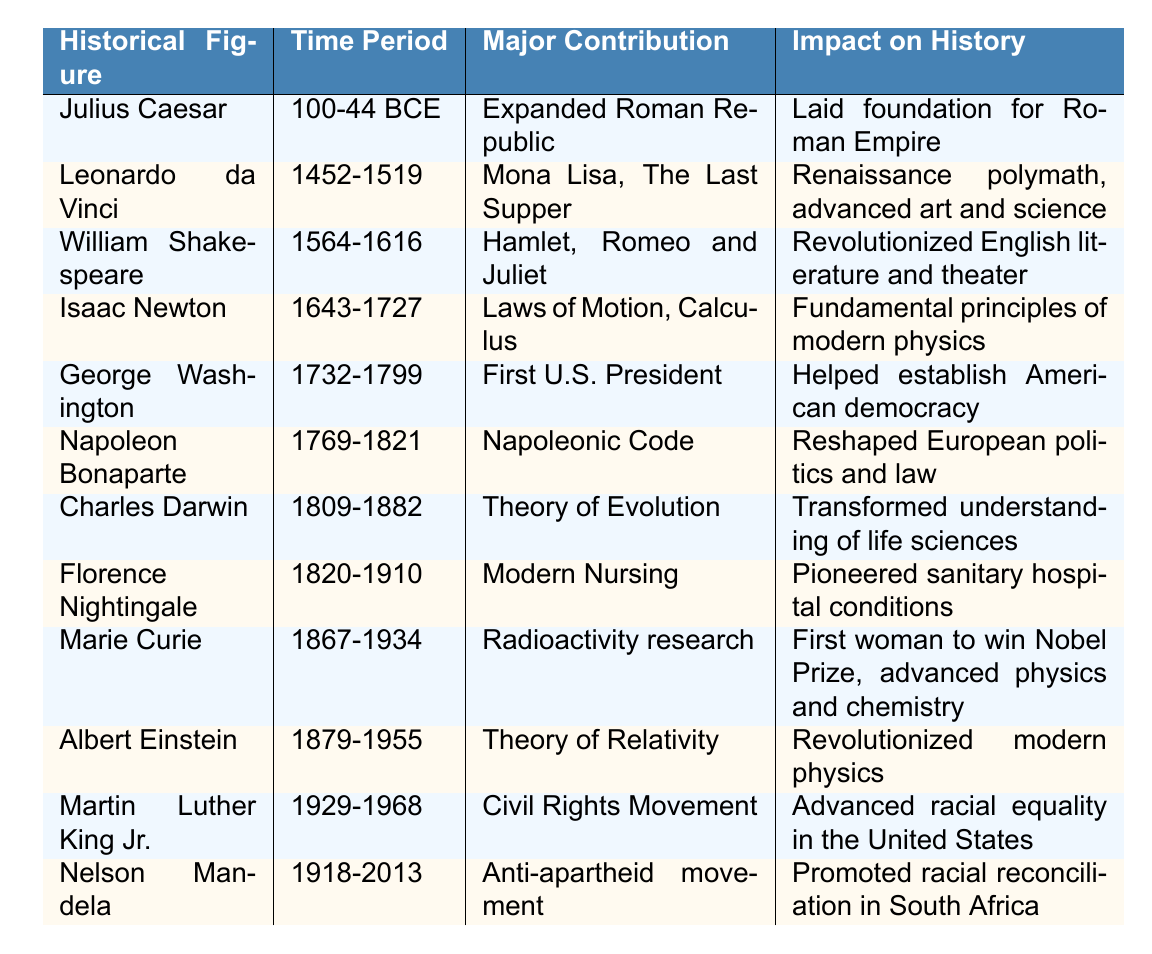What is the major contribution of Isaac Newton? The table displays that Isaac Newton's major contribution is the "Laws of Motion, Calculus." This information is directly found in the row corresponding to Isaac Newton in the table.
Answer: Laws of Motion, Calculus Who was the historical figure associated with the Civil Rights Movement? The table indicates that Martin Luther King Jr. was the historical figure associated with the Civil Rights Movement, as he is listed in that specific row under "Major Contribution."
Answer: Martin Luther King Jr Which figure is noted for their work in modern nursing? According to the table, Florence Nightingale is noted for her work in modern nursing, as stated in her major contribution.
Answer: Florence Nightingale What time period did Charles Darwin live? By examining the data in the table, Charles Darwin's time period is listed as "1809-1882." This information can be directly found in his corresponding row.
Answer: 1809-1882 How many historical figures in the table contributed to the advancement of women in science? The table identifies Marie Curie as a historical figure whose contribution advanced women in science through her radioactivity research. Since only one figure is associated with this context, the answer is 1.
Answer: 1 Did Leonardo da Vinci create the Mona Lisa? The table confirms that Leonardo da Vinci's major contribution includes the "Mona Lisa," thus validating the statement as true.
Answer: Yes What is the impact of Napoleon Bonaparte's contributions? The table specifies that Napoleon Bonaparte's contributions reshaped European politics and law, which reflects his significant impact on history as stated in the "Impact on History" column.
Answer: Reshaped European politics and law Which historical figure's contributions are recognized for transforming understanding in life sciences? According to the table, Charles Darwin's Theory of Evolution is acknowledged for transforming understanding in life sciences, found in his row.
Answer: Charles Darwin List the contributions of figures who lived in the 19th century. Referring to the table, both Charles Darwin (Theory of Evolution) and Florence Nightingale (Modern Nursing) made notable contributions in the 19th century, showing that there are two contributions mentioned.
Answer: 2 contributions Who had a greater historical impact, Julius Caesar or George Washington? The table suggests that both figures had significant historical impacts: Julius Caesar laid the foundation for the Roman Empire, while George Washington helped establish American democracy. It's subjective to determine who had a greater impact since their contributions are in different historical contexts; thus, no definitive conclusion can be reached based purely on the table.
Answer: Cannot determine definitively 